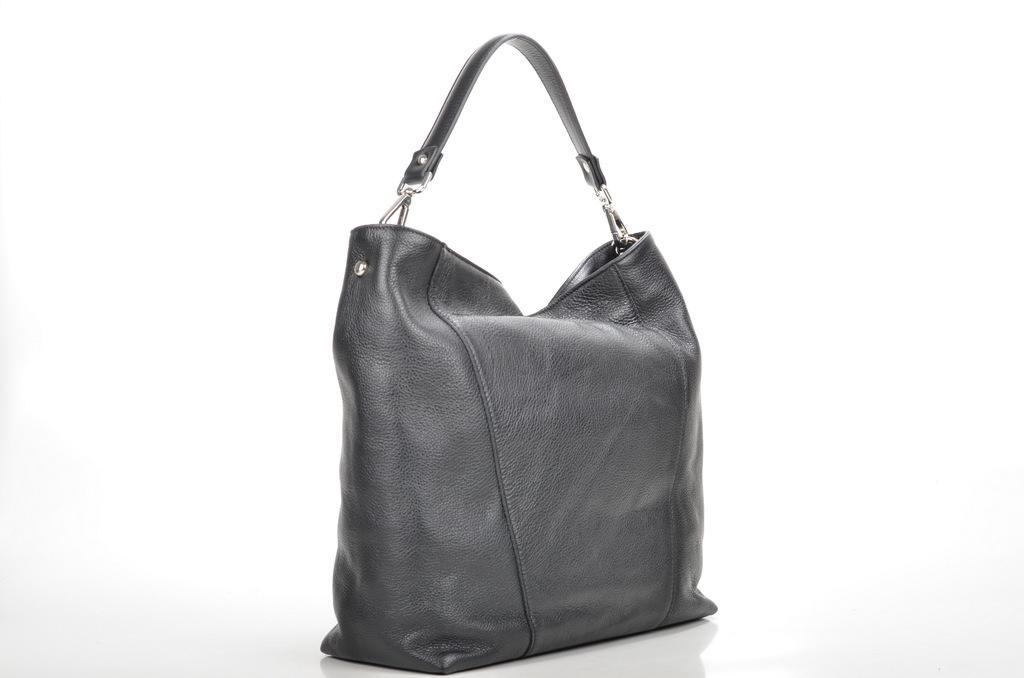Please provide a concise description of this image. In this image i can see a bag. 